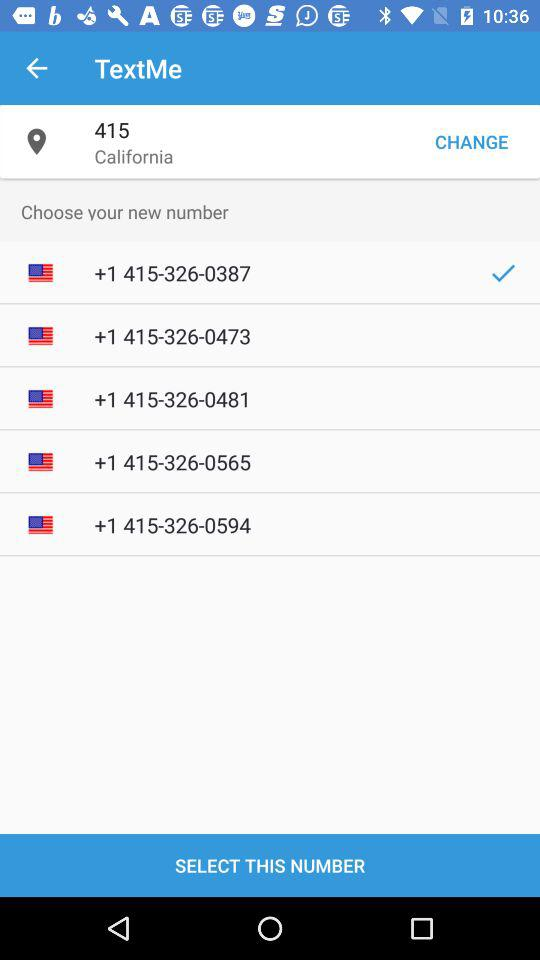What is the location? The location is California. 